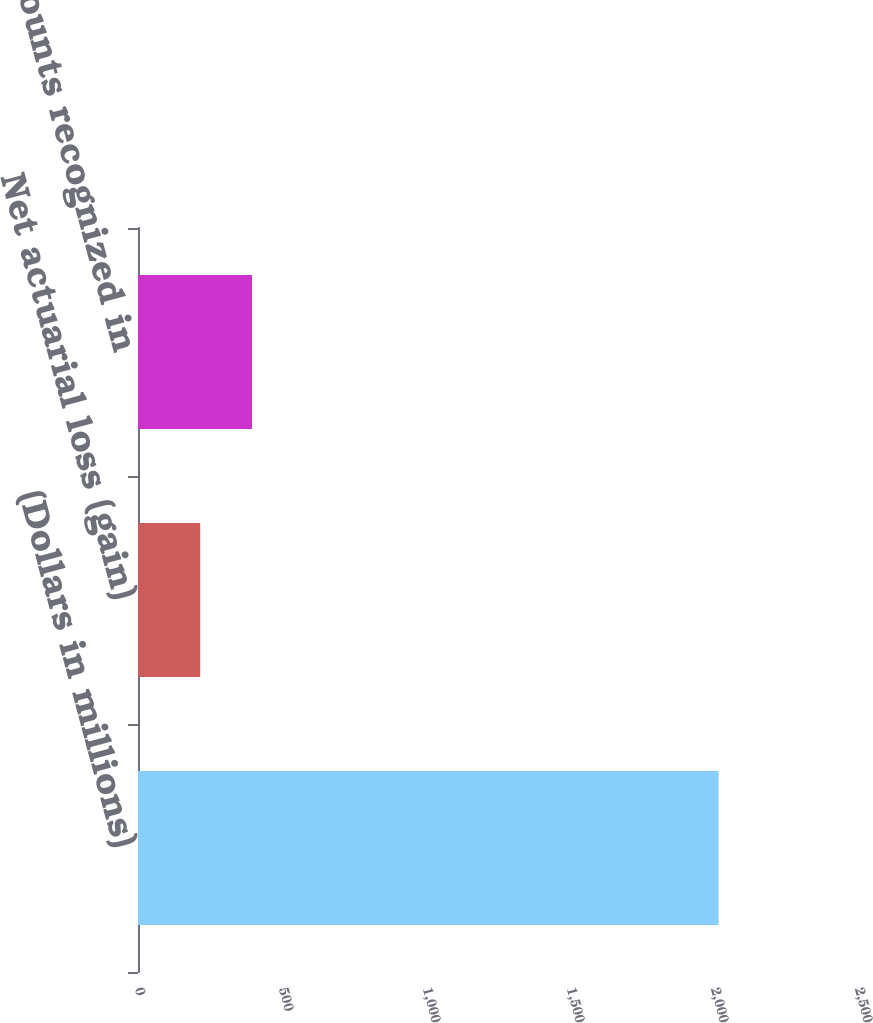Convert chart. <chart><loc_0><loc_0><loc_500><loc_500><bar_chart><fcel>(Dollars in millions)<fcel>Net actuarial loss (gain)<fcel>Amounts recognized in<nl><fcel>2016<fcel>216<fcel>396<nl></chart> 